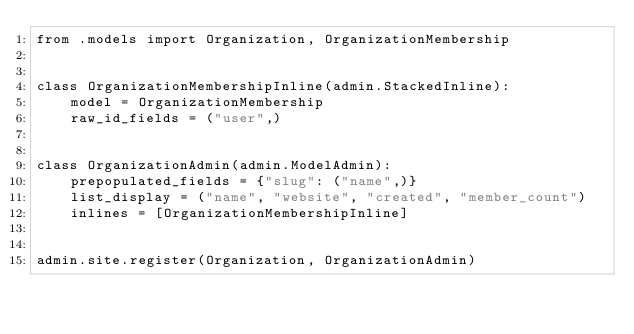<code> <loc_0><loc_0><loc_500><loc_500><_Python_>from .models import Organization, OrganizationMembership


class OrganizationMembershipInline(admin.StackedInline):
    model = OrganizationMembership
    raw_id_fields = ("user",)


class OrganizationAdmin(admin.ModelAdmin):
    prepopulated_fields = {"slug": ("name",)}
    list_display = ("name", "website", "created", "member_count")
    inlines = [OrganizationMembershipInline]


admin.site.register(Organization, OrganizationAdmin)
</code> 